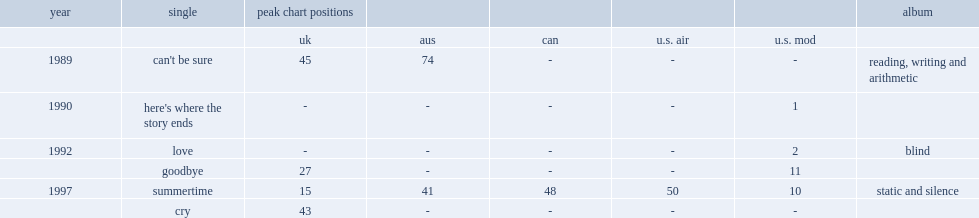When did the sundays release reading, writing and arithmetic? 1990.0. 